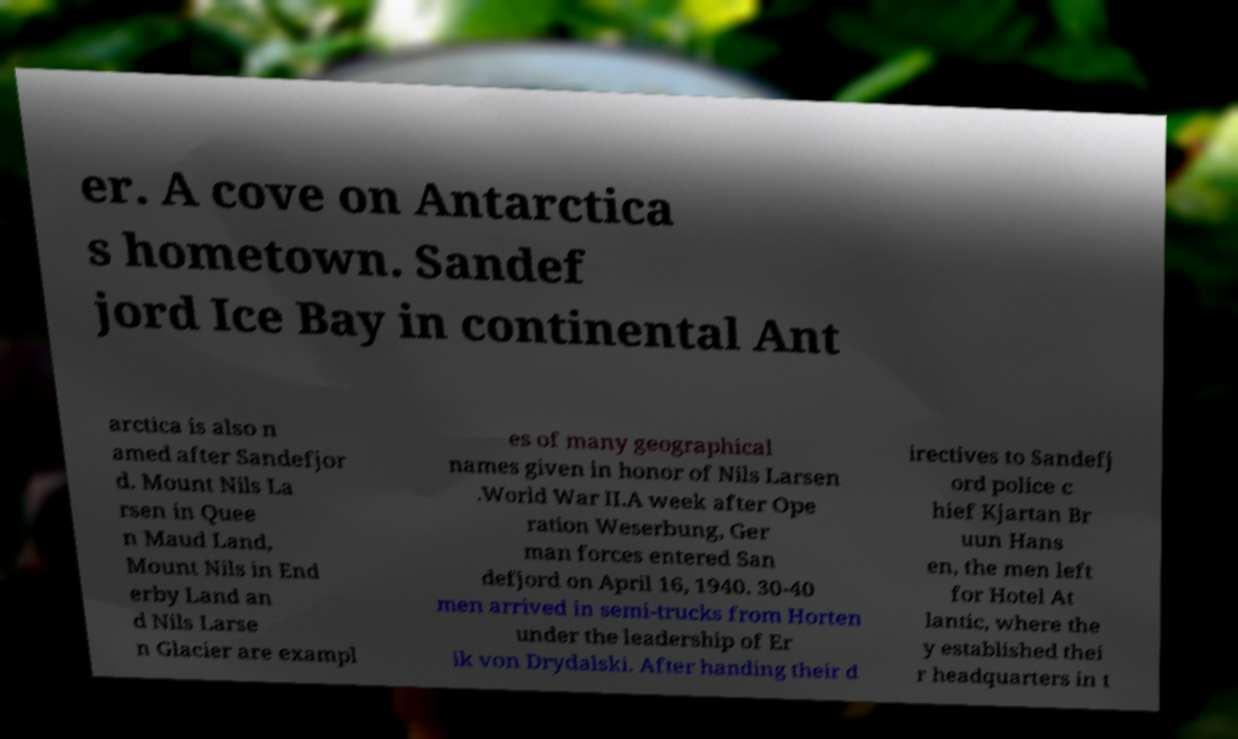I need the written content from this picture converted into text. Can you do that? er. A cove on Antarctica s hometown. Sandef jord Ice Bay in continental Ant arctica is also n amed after Sandefjor d. Mount Nils La rsen in Quee n Maud Land, Mount Nils in End erby Land an d Nils Larse n Glacier are exampl es of many geographical names given in honor of Nils Larsen .World War II.A week after Ope ration Weserbung, Ger man forces entered San defjord on April 16, 1940. 30-40 men arrived in semi-trucks from Horten under the leadership of Er ik von Drydalski. After handing their d irectives to Sandefj ord police c hief Kjartan Br uun Hans en, the men left for Hotel At lantic, where the y established thei r headquarters in t 